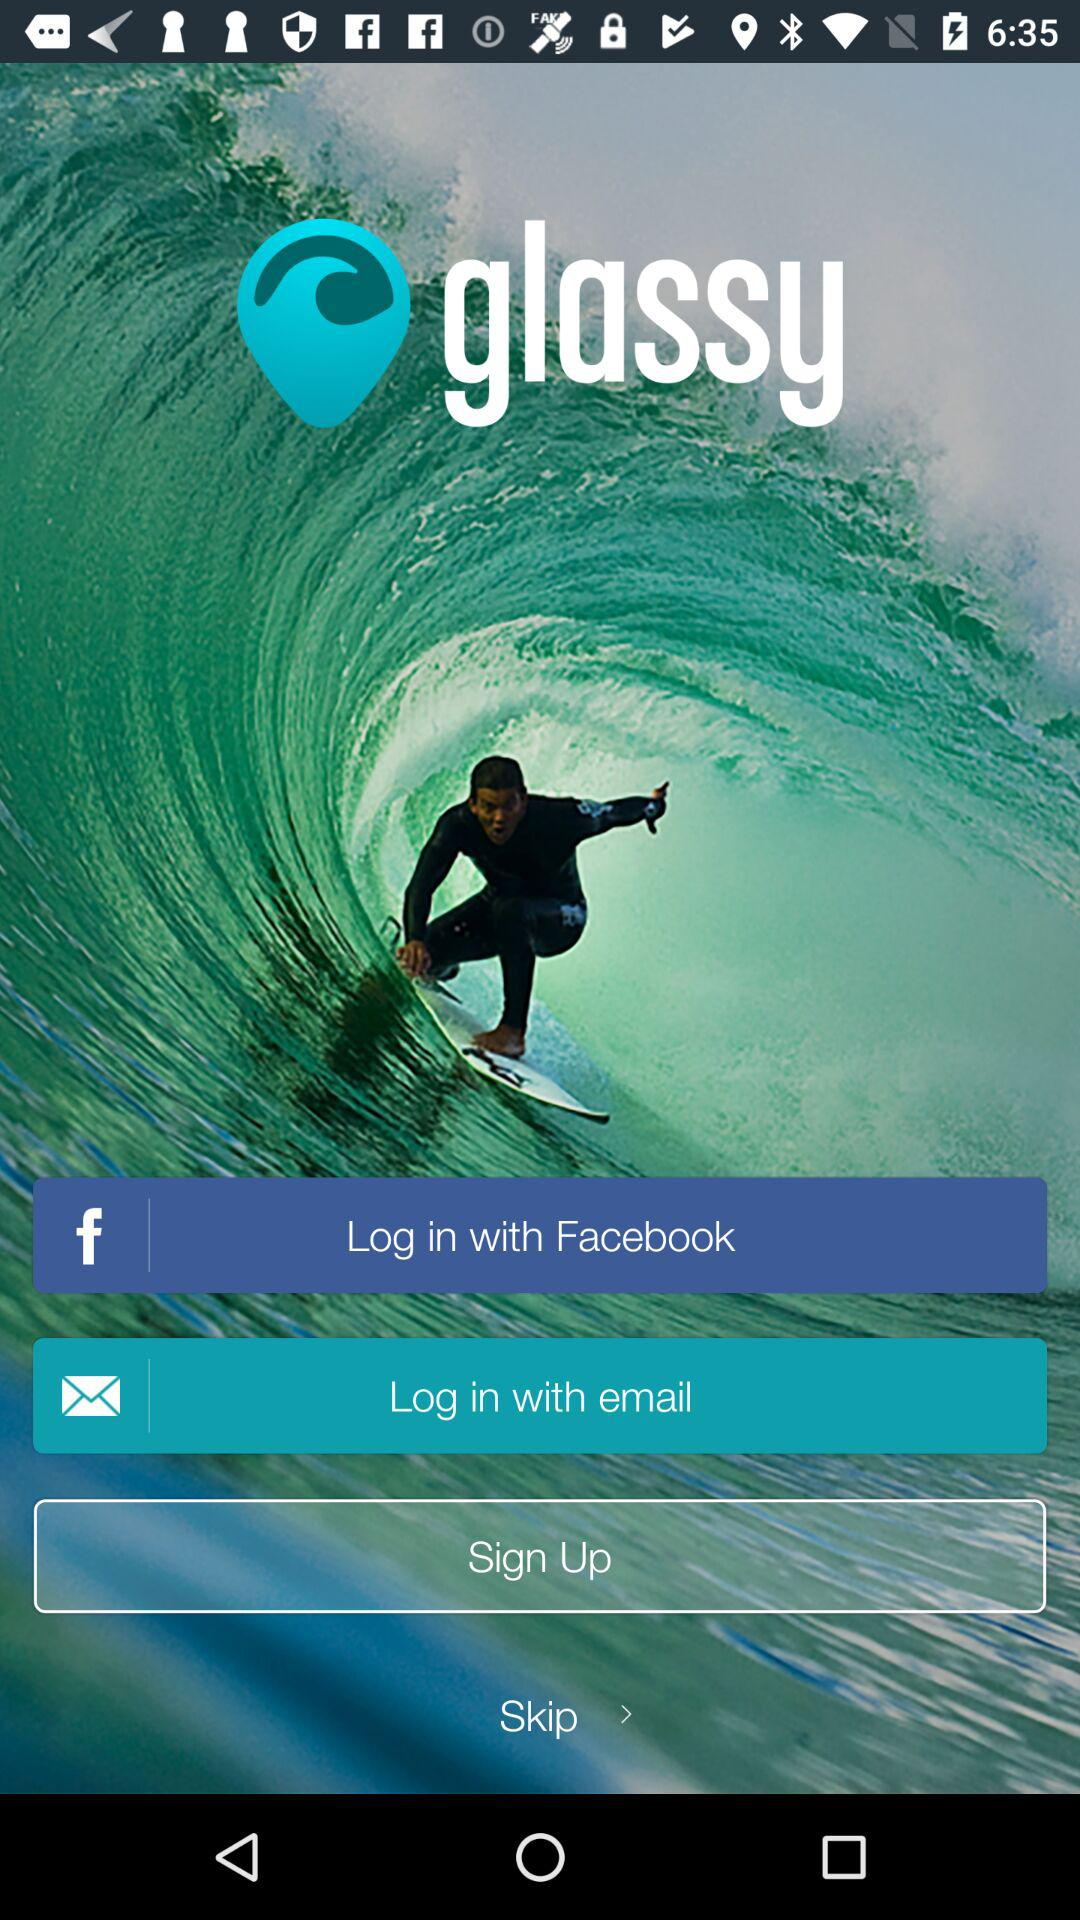What is the application name? The application name is "glassy". 